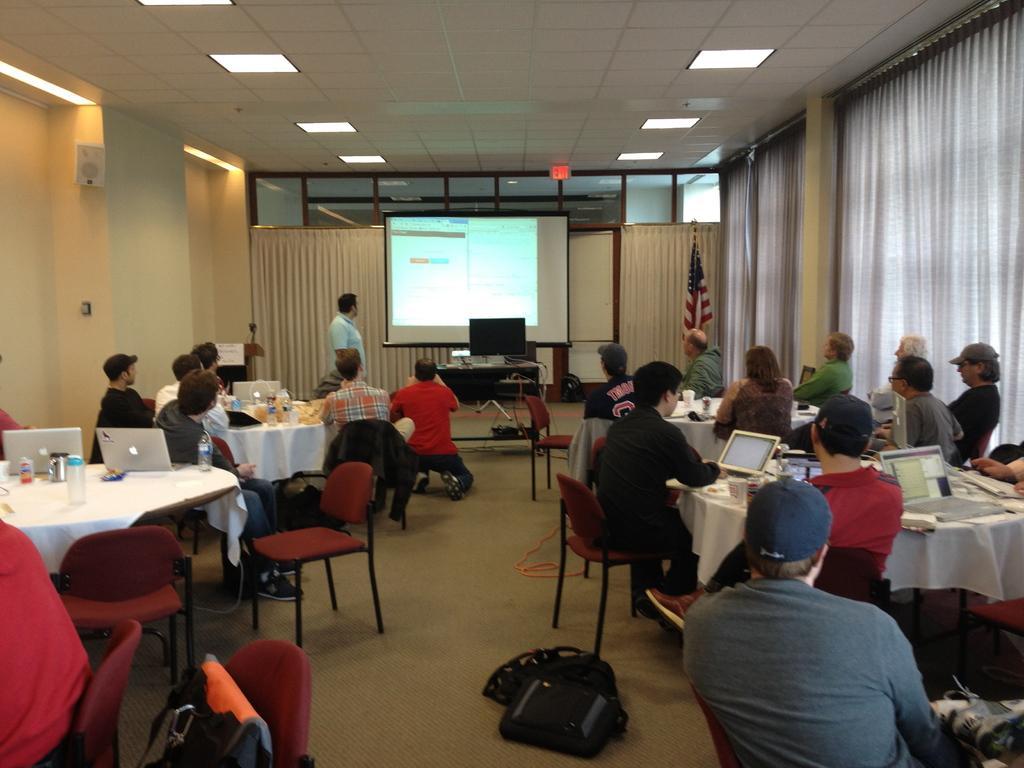Can you describe this image briefly? This image is clicked in a meeting room, on the right side there is curtain on the top there are lights and in the middle there is a screen and system there are so many tablets and laptops on the tables, there are so many chairs. so many people are sitting around tables , there are so many bags, one person is standing and all the other are sitting. 